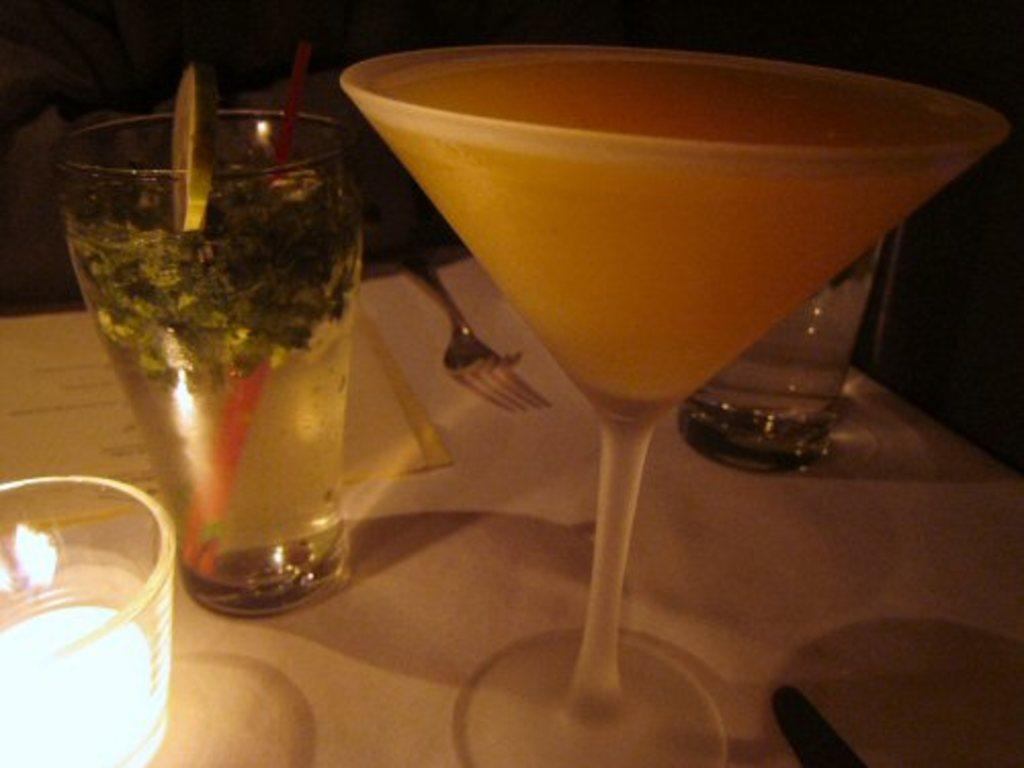What color is the table in the image? The table in the image is white-colored. What is on the table besides the table itself? There are glasses with liquids and a fork visible on the table. Can you describe the lighting in the image? There is a light in the image. How would you describe the overall setting of the image? The background of the image is dark. What type of shoes can be seen in the image? There are no shoes present in the image. What behavior is exhibited by the tub in the image? There is no tub present in the image, so no behavior can be observed. 